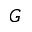<formula> <loc_0><loc_0><loc_500><loc_500>G</formula> 